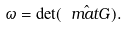<formula> <loc_0><loc_0><loc_500><loc_500>\omega = \det ( { \hat { \ m a t G } } ) .</formula> 